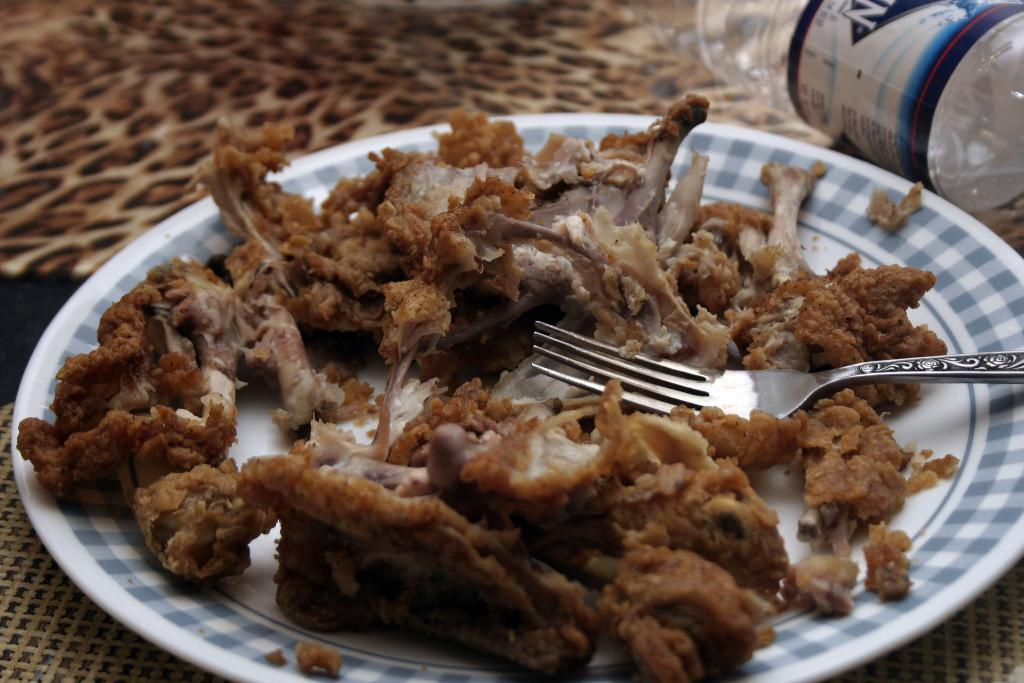What is on the plate that is visible in the image? The plate contains fork and meat items. What other items might be present on the table in the image? There may be a bottle on the table. Where is the image likely taken? The image is likely taken in a room. What sound can be heard coming from the meat in the image? There is no sound coming from the meat in the image, as it is a still photograph. 